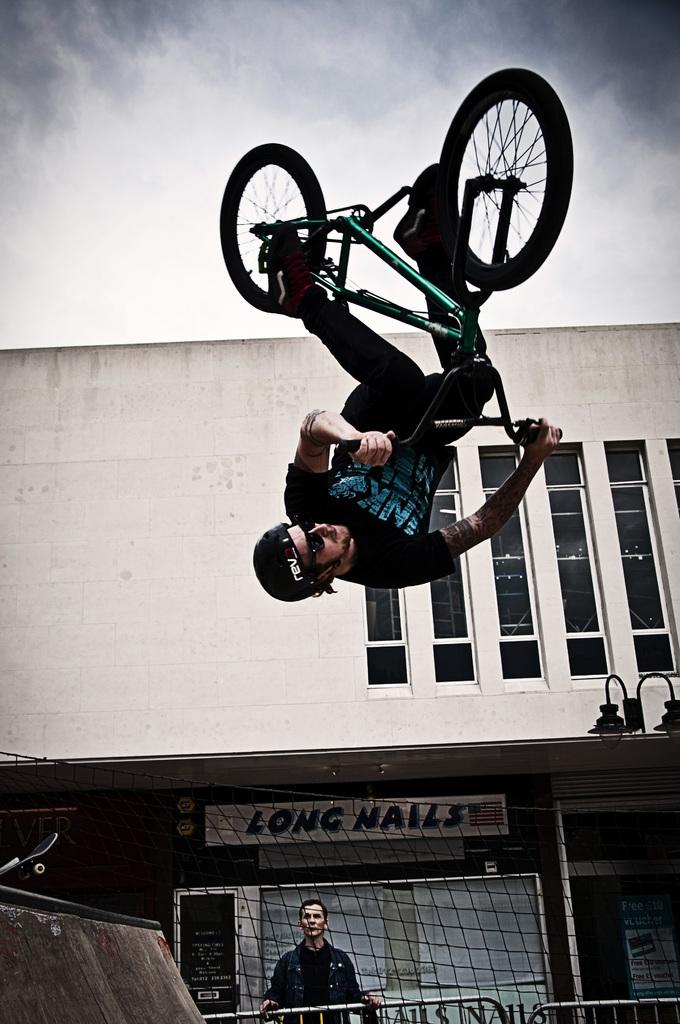What is the main subject of the image? The main subject of the image is a man doing stunts on a cycle. What can be seen in the background of the image? There is a building and a net in the background of the image. Who else is present in the image? Another man is standing in the bottom of the image. How would you describe the weather based on the image? The sky is cloudy in the image, suggesting a potentially overcast or rainy day. Can you tell me how many lakes are visible in the image? There are no lakes visible in the image. What type of door can be seen in the image? There is no door present in the image. 